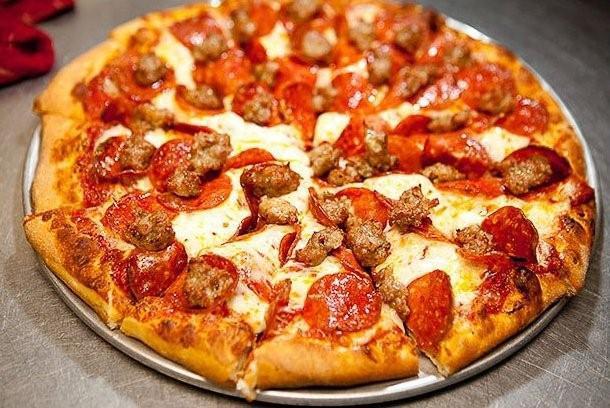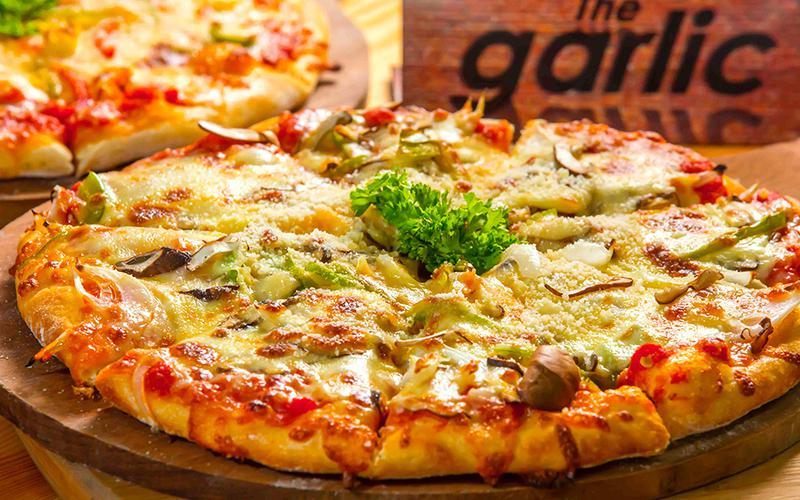The first image is the image on the left, the second image is the image on the right. Evaluate the accuracy of this statement regarding the images: "All of the pizzas are cooked, whole pizzas.". Is it true? Answer yes or no. Yes. The first image is the image on the left, the second image is the image on the right. Given the left and right images, does the statement "There are more pizzas in the image on the right." hold true? Answer yes or no. Yes. 